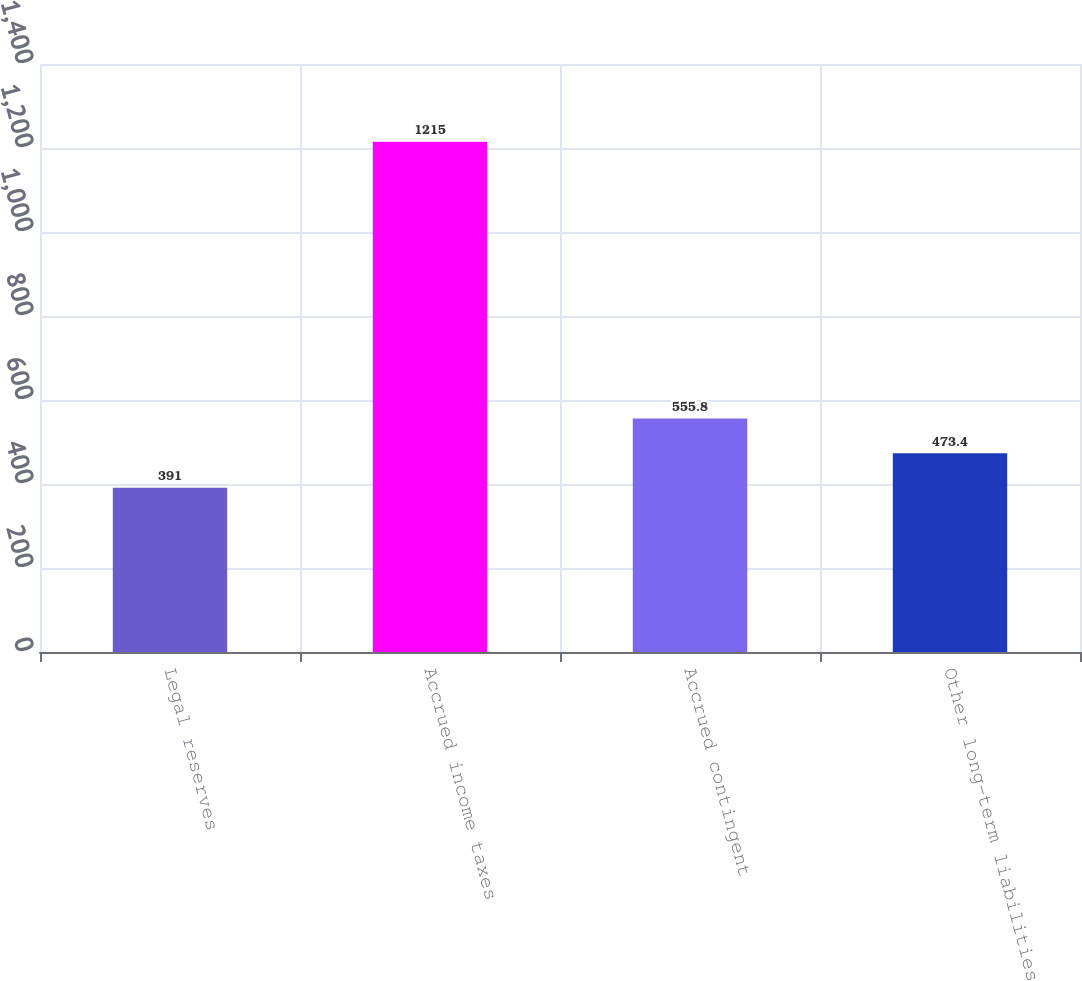<chart> <loc_0><loc_0><loc_500><loc_500><bar_chart><fcel>Legal reserves<fcel>Accrued income taxes<fcel>Accrued contingent<fcel>Other long-term liabilities<nl><fcel>391<fcel>1215<fcel>555.8<fcel>473.4<nl></chart> 